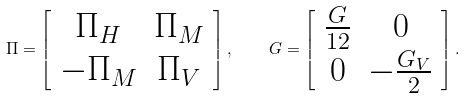<formula> <loc_0><loc_0><loc_500><loc_500>\Pi = \left [ \begin{array} { c c } \Pi _ { H } & \Pi _ { M } \\ - \Pi _ { M } & \Pi _ { V } \end{array} \right ] , \quad G = \left [ \begin{array} { c c } \frac { G } { 1 2 } & 0 \\ 0 & - \frac { G _ { V } } { 2 } \end{array} \right ] .</formula> 